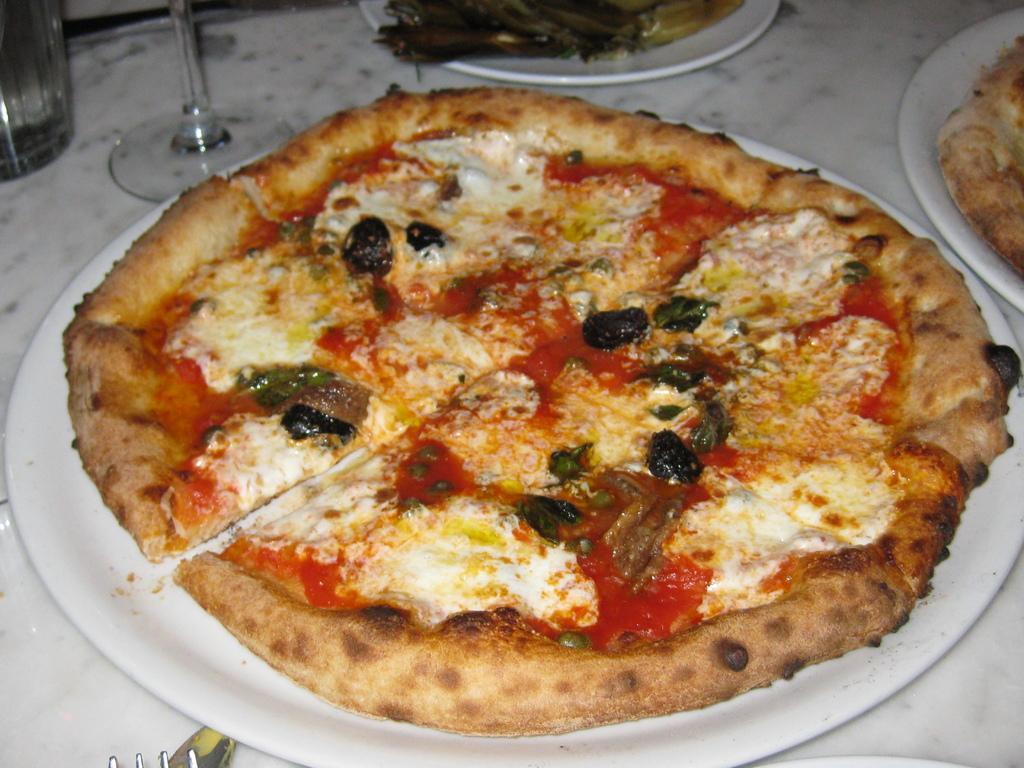Can you describe this image briefly? In this image we can see the plates with some food and glasses on the white color surface, which looks like a table. 